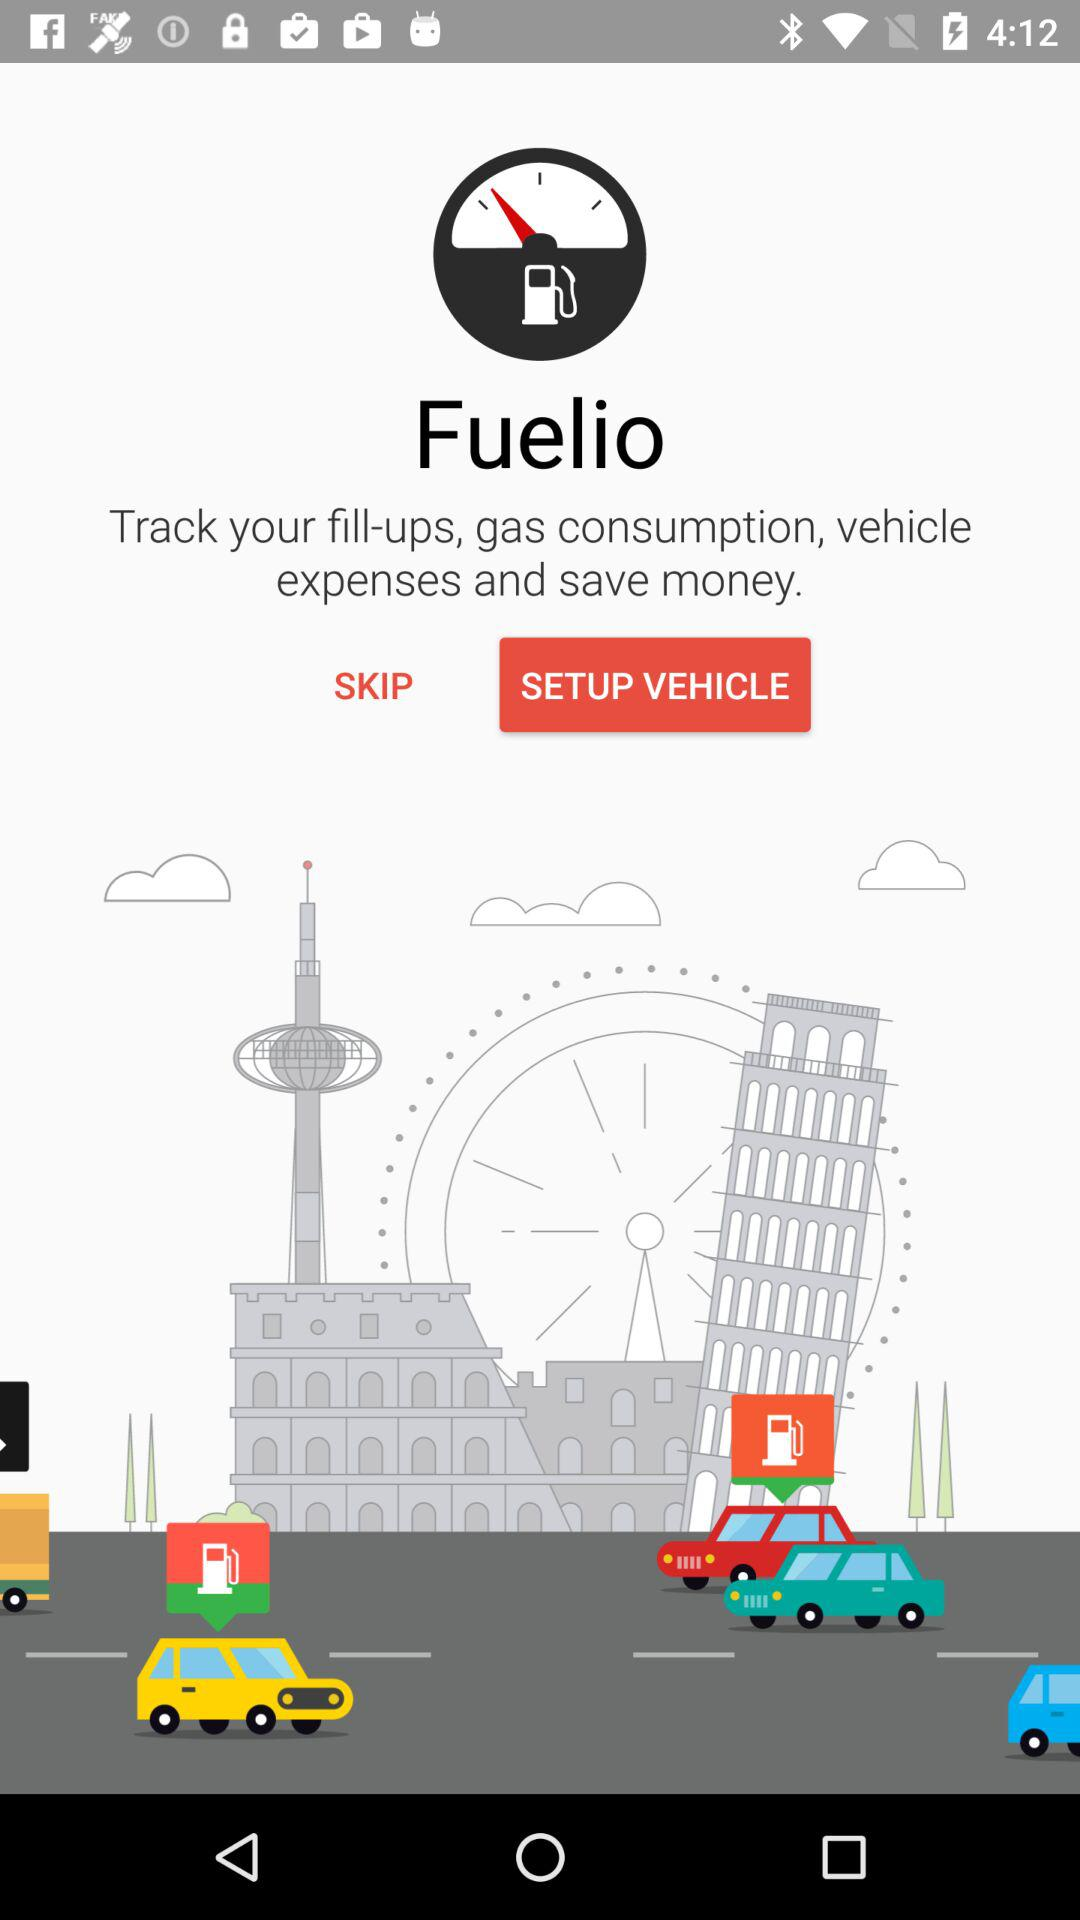What is the name of the application? The name of the application is "Fuelio". 